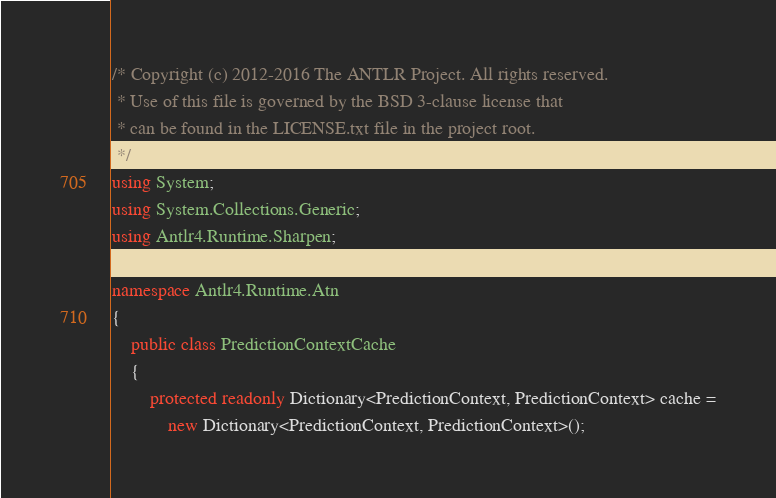Convert code to text. <code><loc_0><loc_0><loc_500><loc_500><_C#_>/* Copyright (c) 2012-2016 The ANTLR Project. All rights reserved.
 * Use of this file is governed by the BSD 3-clause license that
 * can be found in the LICENSE.txt file in the project root.
 */
using System;
using System.Collections.Generic;
using Antlr4.Runtime.Sharpen;

namespace Antlr4.Runtime.Atn
{
	public class PredictionContextCache
	{
		protected readonly Dictionary<PredictionContext, PredictionContext> cache =
			new Dictionary<PredictionContext, PredictionContext>();
</code> 